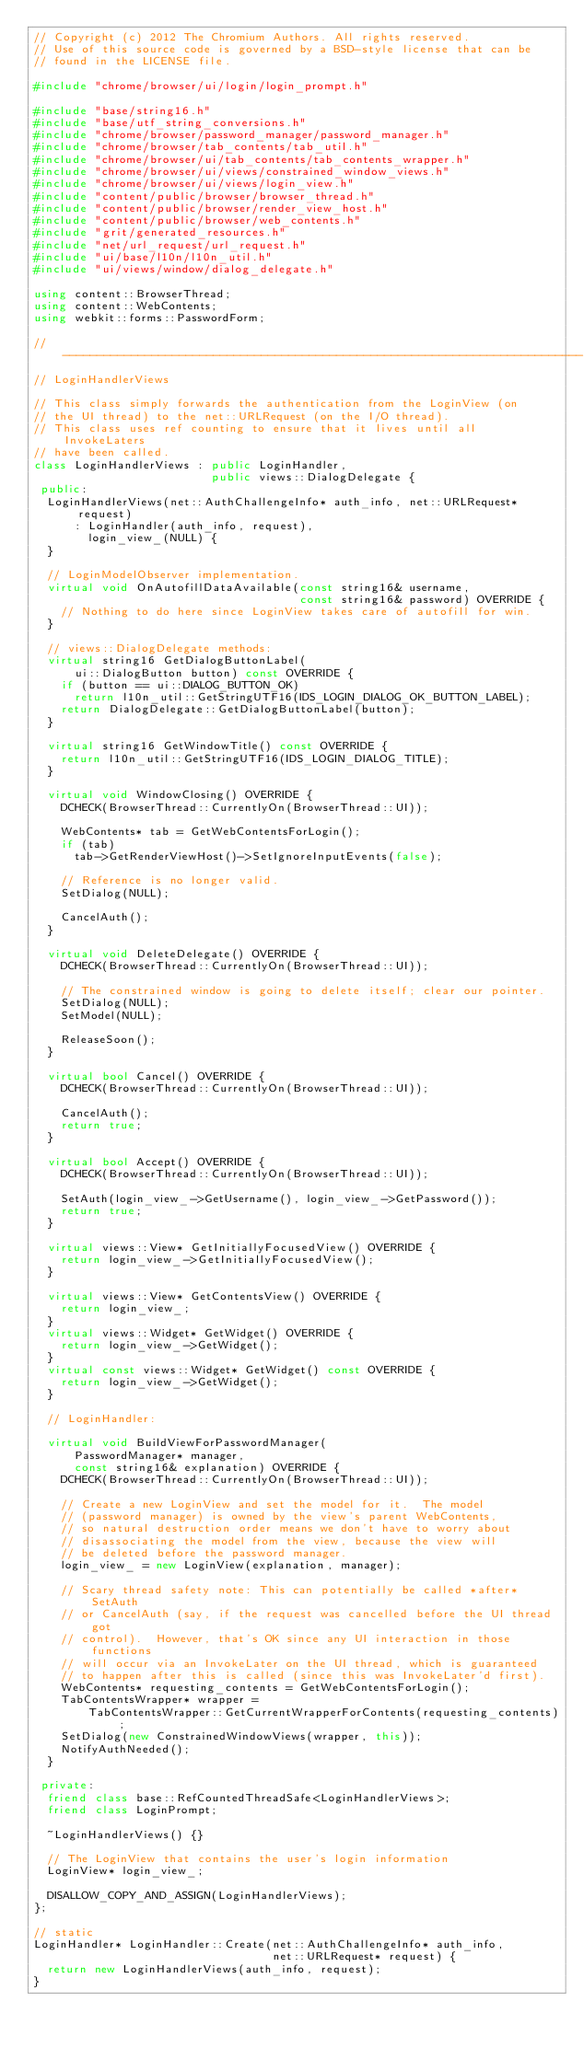Convert code to text. <code><loc_0><loc_0><loc_500><loc_500><_C++_>// Copyright (c) 2012 The Chromium Authors. All rights reserved.
// Use of this source code is governed by a BSD-style license that can be
// found in the LICENSE file.

#include "chrome/browser/ui/login/login_prompt.h"

#include "base/string16.h"
#include "base/utf_string_conversions.h"
#include "chrome/browser/password_manager/password_manager.h"
#include "chrome/browser/tab_contents/tab_util.h"
#include "chrome/browser/ui/tab_contents/tab_contents_wrapper.h"
#include "chrome/browser/ui/views/constrained_window_views.h"
#include "chrome/browser/ui/views/login_view.h"
#include "content/public/browser/browser_thread.h"
#include "content/public/browser/render_view_host.h"
#include "content/public/browser/web_contents.h"
#include "grit/generated_resources.h"
#include "net/url_request/url_request.h"
#include "ui/base/l10n/l10n_util.h"
#include "ui/views/window/dialog_delegate.h"

using content::BrowserThread;
using content::WebContents;
using webkit::forms::PasswordForm;

// ----------------------------------------------------------------------------
// LoginHandlerViews

// This class simply forwards the authentication from the LoginView (on
// the UI thread) to the net::URLRequest (on the I/O thread).
// This class uses ref counting to ensure that it lives until all InvokeLaters
// have been called.
class LoginHandlerViews : public LoginHandler,
                          public views::DialogDelegate {
 public:
  LoginHandlerViews(net::AuthChallengeInfo* auth_info, net::URLRequest* request)
      : LoginHandler(auth_info, request),
        login_view_(NULL) {
  }

  // LoginModelObserver implementation.
  virtual void OnAutofillDataAvailable(const string16& username,
                                       const string16& password) OVERRIDE {
    // Nothing to do here since LoginView takes care of autofill for win.
  }

  // views::DialogDelegate methods:
  virtual string16 GetDialogButtonLabel(
      ui::DialogButton button) const OVERRIDE {
    if (button == ui::DIALOG_BUTTON_OK)
      return l10n_util::GetStringUTF16(IDS_LOGIN_DIALOG_OK_BUTTON_LABEL);
    return DialogDelegate::GetDialogButtonLabel(button);
  }

  virtual string16 GetWindowTitle() const OVERRIDE {
    return l10n_util::GetStringUTF16(IDS_LOGIN_DIALOG_TITLE);
  }

  virtual void WindowClosing() OVERRIDE {
    DCHECK(BrowserThread::CurrentlyOn(BrowserThread::UI));

    WebContents* tab = GetWebContentsForLogin();
    if (tab)
      tab->GetRenderViewHost()->SetIgnoreInputEvents(false);

    // Reference is no longer valid.
    SetDialog(NULL);

    CancelAuth();
  }

  virtual void DeleteDelegate() OVERRIDE {
    DCHECK(BrowserThread::CurrentlyOn(BrowserThread::UI));

    // The constrained window is going to delete itself; clear our pointer.
    SetDialog(NULL);
    SetModel(NULL);

    ReleaseSoon();
  }

  virtual bool Cancel() OVERRIDE {
    DCHECK(BrowserThread::CurrentlyOn(BrowserThread::UI));

    CancelAuth();
    return true;
  }

  virtual bool Accept() OVERRIDE {
    DCHECK(BrowserThread::CurrentlyOn(BrowserThread::UI));

    SetAuth(login_view_->GetUsername(), login_view_->GetPassword());
    return true;
  }

  virtual views::View* GetInitiallyFocusedView() OVERRIDE {
    return login_view_->GetInitiallyFocusedView();
  }

  virtual views::View* GetContentsView() OVERRIDE {
    return login_view_;
  }
  virtual views::Widget* GetWidget() OVERRIDE {
    return login_view_->GetWidget();
  }
  virtual const views::Widget* GetWidget() const OVERRIDE {
    return login_view_->GetWidget();
  }

  // LoginHandler:

  virtual void BuildViewForPasswordManager(
      PasswordManager* manager,
      const string16& explanation) OVERRIDE {
    DCHECK(BrowserThread::CurrentlyOn(BrowserThread::UI));

    // Create a new LoginView and set the model for it.  The model
    // (password manager) is owned by the view's parent WebContents,
    // so natural destruction order means we don't have to worry about
    // disassociating the model from the view, because the view will
    // be deleted before the password manager.
    login_view_ = new LoginView(explanation, manager);

    // Scary thread safety note: This can potentially be called *after* SetAuth
    // or CancelAuth (say, if the request was cancelled before the UI thread got
    // control).  However, that's OK since any UI interaction in those functions
    // will occur via an InvokeLater on the UI thread, which is guaranteed
    // to happen after this is called (since this was InvokeLater'd first).
    WebContents* requesting_contents = GetWebContentsForLogin();
    TabContentsWrapper* wrapper =
        TabContentsWrapper::GetCurrentWrapperForContents(requesting_contents);
    SetDialog(new ConstrainedWindowViews(wrapper, this));
    NotifyAuthNeeded();
  }

 private:
  friend class base::RefCountedThreadSafe<LoginHandlerViews>;
  friend class LoginPrompt;

  ~LoginHandlerViews() {}

  // The LoginView that contains the user's login information
  LoginView* login_view_;

  DISALLOW_COPY_AND_ASSIGN(LoginHandlerViews);
};

// static
LoginHandler* LoginHandler::Create(net::AuthChallengeInfo* auth_info,
                                   net::URLRequest* request) {
  return new LoginHandlerViews(auth_info, request);
}
</code> 